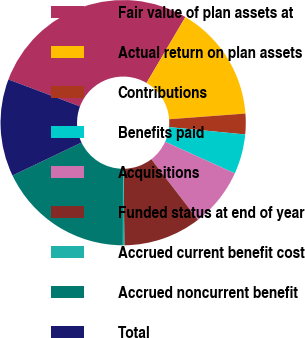<chart> <loc_0><loc_0><loc_500><loc_500><pie_chart><fcel>Fair value of plan assets at<fcel>Actual return on plan assets<fcel>Contributions<fcel>Benefits paid<fcel>Acquisitions<fcel>Funded status at end of year<fcel>Accrued current benefit cost<fcel>Accrued noncurrent benefit<fcel>Total<nl><fcel>27.74%<fcel>15.34%<fcel>2.72%<fcel>5.25%<fcel>7.77%<fcel>10.29%<fcel>0.2%<fcel>17.87%<fcel>12.82%<nl></chart> 